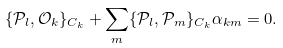<formula> <loc_0><loc_0><loc_500><loc_500>\{ { \mathcal { P } } _ { l } , { \mathcal { O } } _ { k } \} _ { { C } _ { k } } + \sum _ { m } \{ { \mathcal { P } } _ { l } , { \mathcal { P } } _ { m } \} _ { { C } _ { k } } \alpha _ { k m } = 0 .</formula> 